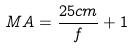<formula> <loc_0><loc_0><loc_500><loc_500>M A = \frac { 2 5 c m } { f } + 1</formula> 